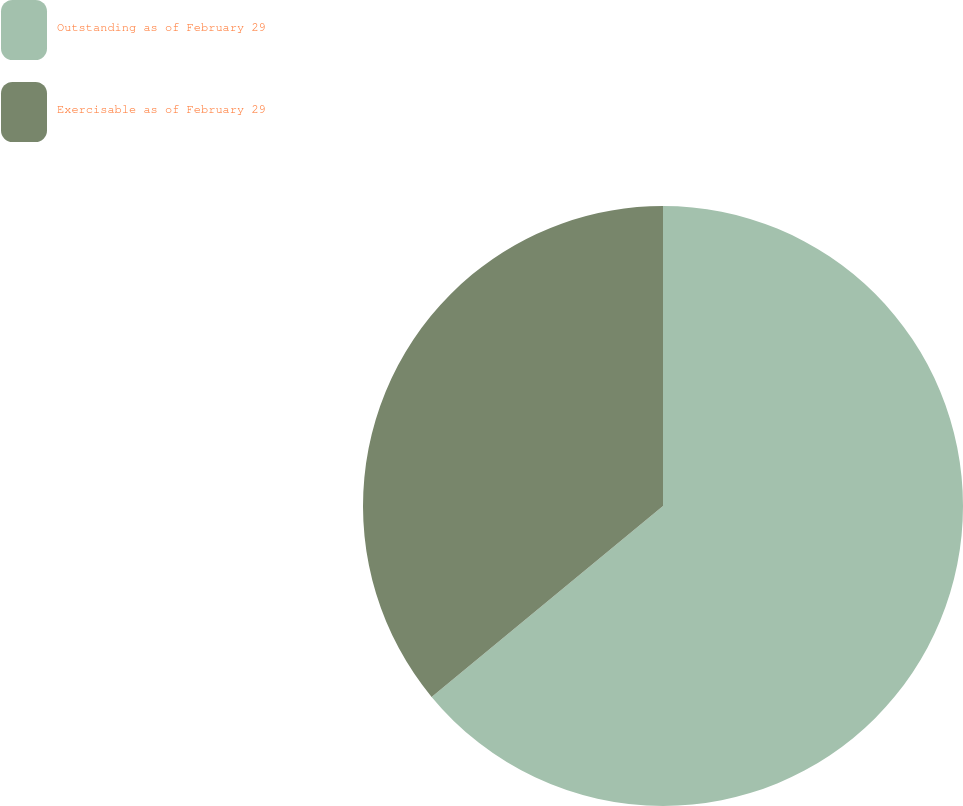Convert chart. <chart><loc_0><loc_0><loc_500><loc_500><pie_chart><fcel>Outstanding as of February 29<fcel>Exercisable as of February 29<nl><fcel>64.02%<fcel>35.98%<nl></chart> 